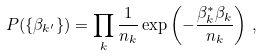<formula> <loc_0><loc_0><loc_500><loc_500>P ( \{ \beta _ { k ^ { \prime } } \} ) = \prod _ { k } \frac { 1 } { n _ { k } } \exp \left ( - \frac { \beta _ { k } ^ { * } \beta _ { k } } { n _ { k } } \right ) \, ,</formula> 